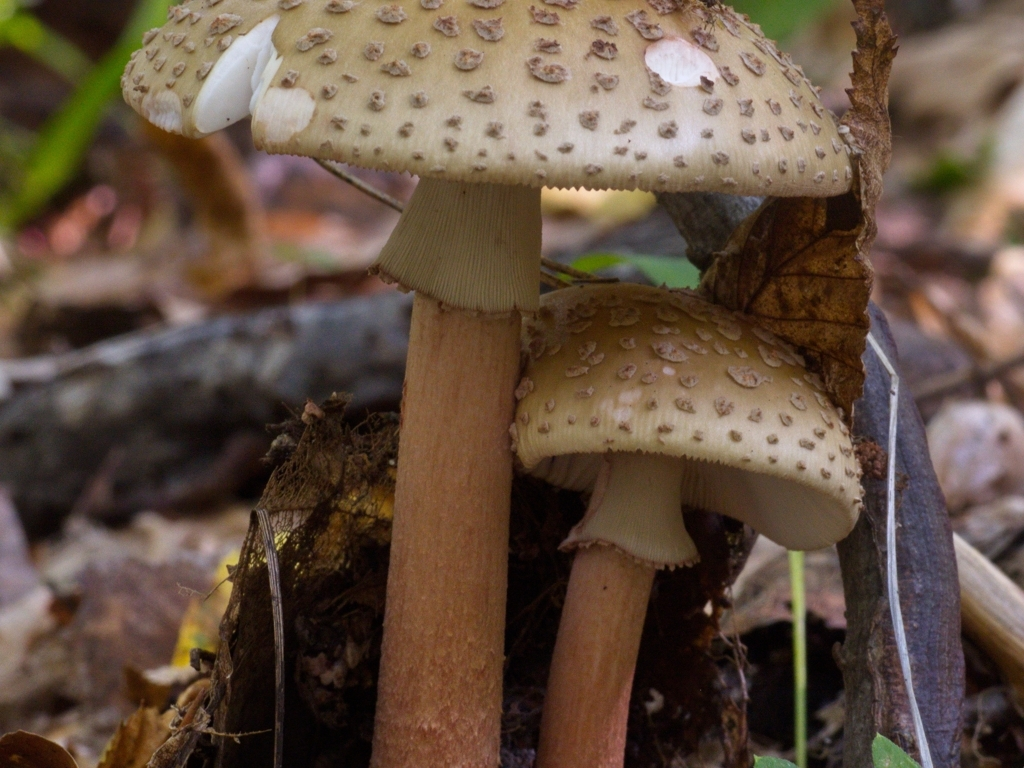Could you describe the composition of this photograph? The composition of the photograph is carefully constructed to emphasize the mushrooms as the main subject. Their placement in the foreground, coupled with a shallow depth of field, ensures they are the main focus. The out-of-focus background adds depth to the image without competing for the viewer's attention. The color palette is earthy and natural, which further highlights the organic beauty of the scene. What might be the significance of the broken cap on one of the mushrooms? The broken cap on the mushroom adds a narrative element to the image. It may suggest recent animal activity, as animals are known to forage mushrooms, or it could indicate the natural decaying process as the mushroom matures. This element of imperfection also brings a touch of realism to the photograph, highlighting the transient nature of life in the forest. 